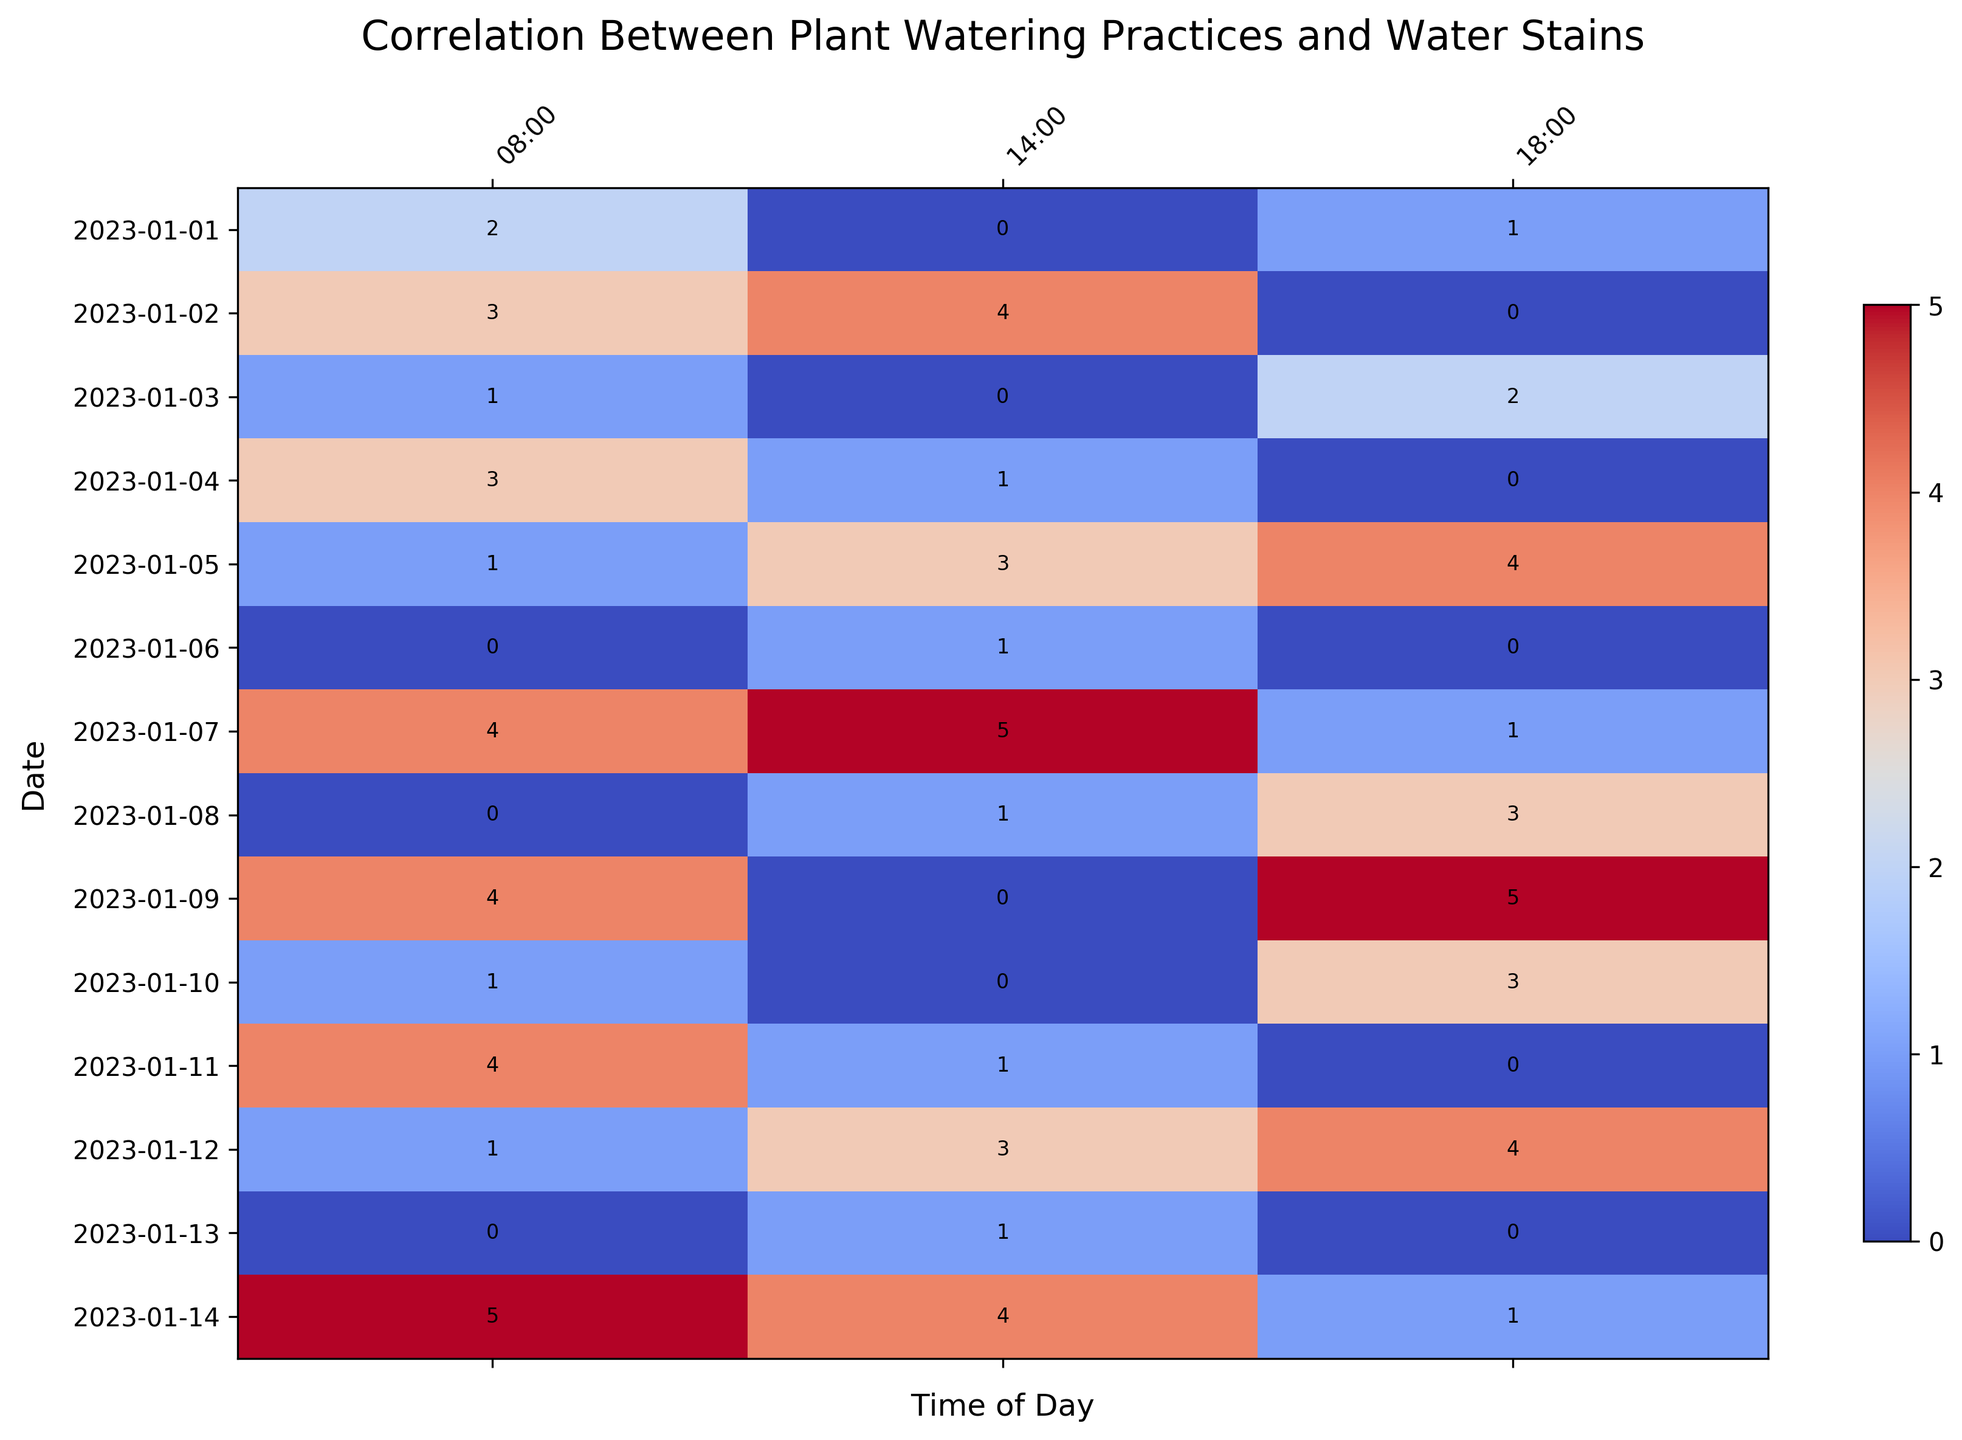What's the most common time of day when generous watering practices result in water stains? By observing the heatmap, look for consistently high values for "Generous" watering across different times. Focus on the darkest red cells, indicating higher reports of stains. Note the repetitive pattern in the column corresponding to the specific times of day.
Answer: 14:00 Compare the average number of reported water stains during generous vs. sparse watering practices. Which is higher? Sum all reported stains for "Generous" and "Sparse" watering and divide by their respective counts. For "Generous": (2+3+4+2+3+4+4+5+3+4+5+3+4) / 13 = 3.54. For "Sparse": (0+0+0+0+0+0+0+0+0+0+0) / 11 = 0. Thus, generous watering results in a higher average.
Answer: Generous Which specific time of day has the least reported water stains on average? Observe the heatmap and find the column with the lightest colors over multiple cells, indicating fewer stains. Calculate the average stains for each column/time slot and compare.
Answer: 18:00 Is there a specific date where no water stains were reported, regardless of the watering practice? Scan the rows in the heatmap for any date where all cells have a numerical value of Zero stain reports.
Answer: No, all dates have some reported stains What's the trend in reported water stains when comparing normal and generous watering practices? Which one tends to result in more stains? Compare the numerical values in the heatmap for "Normal" and "Generous" practices. Count the number of times high values (dark red) appear for both and summarize the trend. Higher counts of dark red imply more stains.
Answer: Generous On which date do we observe the highest number of total reported stains? Sum the reported stains for each date by viewing all cells in the corresponding row and comparing these sums. The row with the darkest cells and visually more water stains will be the highest.
Answer: 2023-01-07 When observing only normal watering practices, is there a particular time of day with consistently fewer stains? Look specifically at cells corresponding to "Normal" watering and compare the values for different times of day. Focus on lighter colored cells indicating fewer stains.
Answer: 14:00 How does the variation in stains reported at 08:00 compare between sparse and normal watering practices? Compare the values at 08:00 for "Sparse" and "Normal" practices by tallying up the numbers in the respective columns. Note if one practice consistently has higher or lower values.
Answer: Sparse consistently has fewer stains at 08:00 Is there a specific pattern or cycle in water stain reports when observing generous watering every third day at 18:00? Check every third day in the 18:00 column for "Generous" watering to see if there's a cyclical high or low pattern in reported stains, generally highlighted by dark or light cells.
Answer: Yes, there are recurring high stains (dark red) every third day in "Generous" at 18:00 